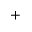<formula> <loc_0><loc_0><loc_500><loc_500>^ { + }</formula> 